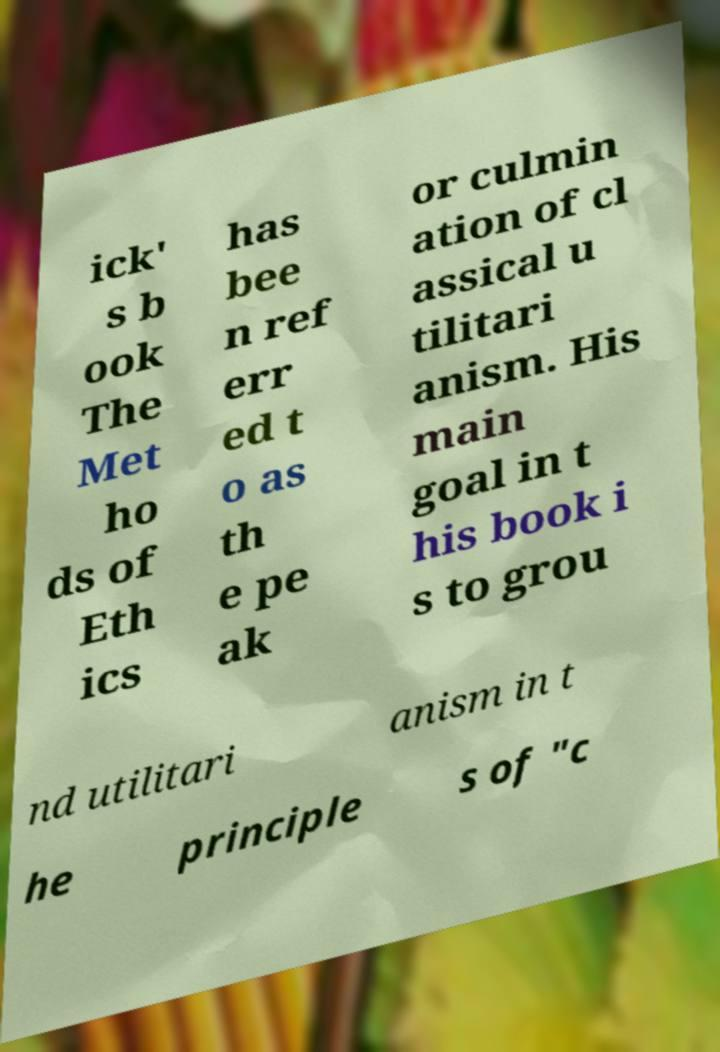Please identify and transcribe the text found in this image. ick' s b ook The Met ho ds of Eth ics has bee n ref err ed t o as th e pe ak or culmin ation of cl assical u tilitari anism. His main goal in t his book i s to grou nd utilitari anism in t he principle s of "c 